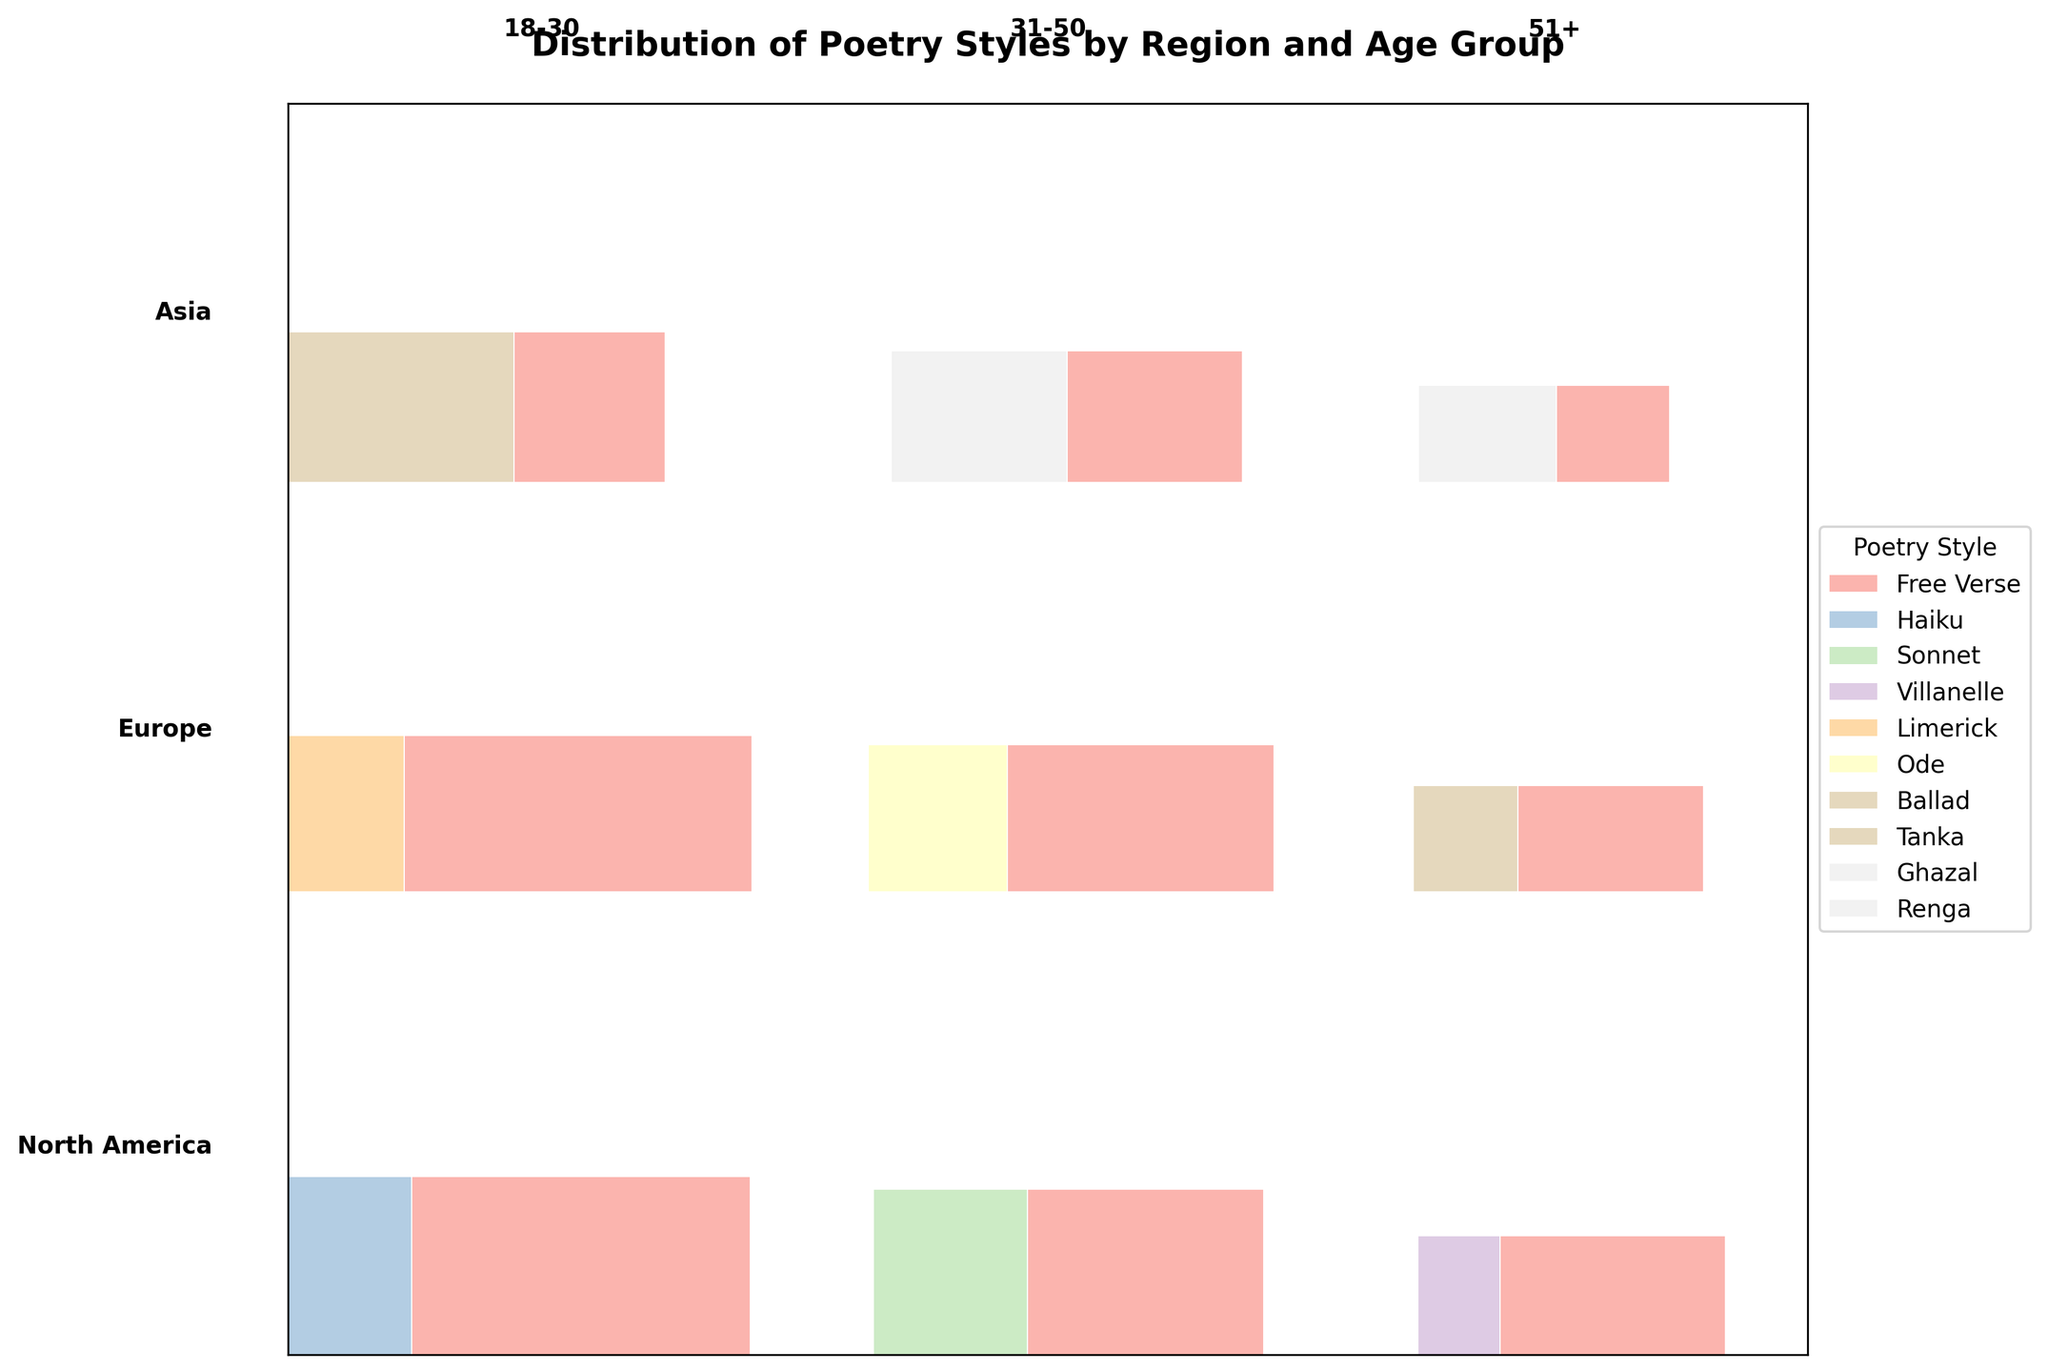What is the title of the figure? The title is usually the most prominent text at the top of the figure. It provides a brief summary or description of what the figure is about. In this case, the title is "Distribution of Poetry Styles by Region and Age Group".
Answer: Distribution of Poetry Styles by Region and Age Group What regions are represented in the figure? The regions are typically listed in the data and also labeled on the figure. For this mosaic plot, the regions represented are North America, Europe, and Asia.
Answer: North America, Europe, Asia Which poetry style is the most common among poets aged 18-30 in North America? To determine this, you would look at the segment corresponding to North America and the 18-30 age group. The largest segment in that category represents the most common poetry style. According to the figure, the largest segment is "Free Verse".
Answer: Free Verse How does the proportion of Free Verse poets in Europe compare between the 18-30 and 31-50 age groups? This involves comparing the height of the rectangles for Free Verse in Europe between the two age groups. The one with a larger height represents a greater proportion. From the figure, the 18-30 age group has a slightly larger proportion than the 31-50 age group.
Answer: 18-30 > 31-50 Which poetry style appears uniquely in one region, and which region is it? To find this, you need to identify the poetry style that is present in only one region and not the others. In this case, "Renga" appears only in the Asia region.
Answer: Renga, Asia In which age group is Haiku most popular in North America? Check the North America section and look for the rectangles representing different age groups. The age group with the largest Haiku segment will be the most popular age group. From the figure, Haiku is most popular in the 18-30 age group.
Answer: 18-30 Compare the total counts of Tanka in Asia and Limerick in Europe. Which one is higher? Look at the segments for Tanka in Asia and Limerick in Europe, and compare their sizes. The one with a larger rectangle represents a higher count. According to the figure, Tanka in Asia has a higher count than Limerick in Europe.
Answer: Tanka is higher What is the least popular poetry style among poets aged 51+ in North America? For this, look at the height of each rectangle in the North America region for poets aged 51+. The smallest rectangle represents the least popular poetry style. The figure shows that "Villanelle" is the least popular style in this group.
Answer: Villanelle Calculate the total number of poets aged 31-50 in all regions who prefer Free Verse. Sum the counts of Free Verse poets aged 31-50 across all regions. According to the data: North America has 38, Europe has 35, and Asia has 28. The total is 38 + 35 + 28 = 101.
Answer: 101 Which age group has the highest diversity in poetry styles in Asia? Diversity in poetry styles can be interpreted as having multiple poetry styles with relatively significant proportions. By comparing the age groups in the Asia region, the 18-30 age group shows a more diverse set of poetry styles with Free Verse and Tanka having notable proportions.
Answer: 18-30 